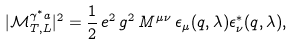Convert formula to latex. <formula><loc_0><loc_0><loc_500><loc_500>| \mathcal { M } _ { T , L } ^ { \gamma ^ { * } a } | ^ { 2 } = \frac { 1 } { 2 } \, e ^ { 2 } \, g ^ { 2 } \, M ^ { \mu \nu } \, \epsilon _ { \mu } ( q , \lambda ) \epsilon _ { \nu } ^ { * } ( q , \lambda ) ,</formula> 